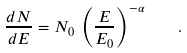Convert formula to latex. <formula><loc_0><loc_0><loc_500><loc_500>\frac { d N } { d E } = N _ { 0 } \, \left ( \frac { E } { E _ { 0 } } \right ) ^ { - \alpha } \quad .</formula> 